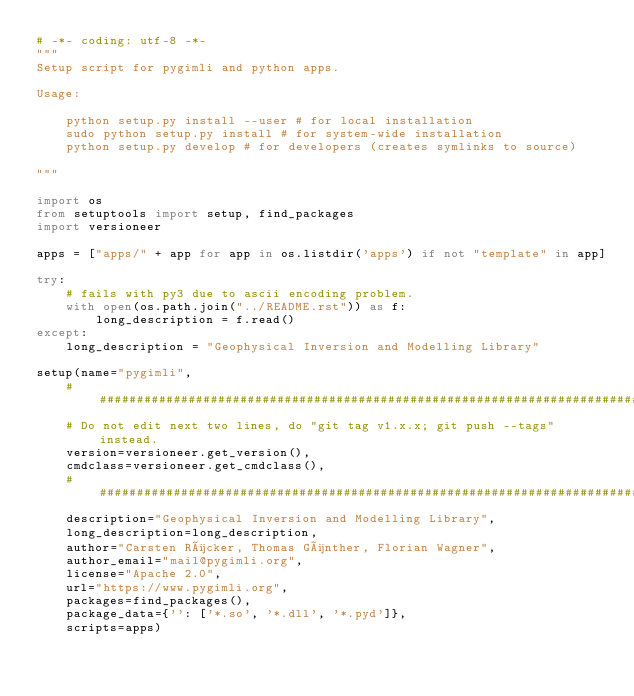<code> <loc_0><loc_0><loc_500><loc_500><_Python_># -*- coding: utf-8 -*-
"""
Setup script for pygimli and python apps.

Usage:

    python setup.py install --user # for local installation
    sudo python setup.py install # for system-wide installation
    python setup.py develop # for developers (creates symlinks to source)

"""

import os
from setuptools import setup, find_packages
import versioneer

apps = ["apps/" + app for app in os.listdir('apps') if not "template" in app]

try:
    # fails with py3 due to ascii encoding problem.
    with open(os.path.join("../README.rst")) as f:
        long_description = f.read()
except:
    long_description = "Geophysical Inversion and Modelling Library"

setup(name="pygimli",
    ############################################################################
    # Do not edit next two lines, do "git tag v1.x.x; git push --tags" instead.
    version=versioneer.get_version(),
    cmdclass=versioneer.get_cmdclass(),
    ############################################################################
    description="Geophysical Inversion and Modelling Library",
    long_description=long_description,
    author="Carsten Rücker, Thomas Günther, Florian Wagner",
    author_email="mail@pygimli.org",
    license="Apache 2.0",
    url="https://www.pygimli.org",
    packages=find_packages(),
    package_data={'': ['*.so', '*.dll', '*.pyd']},
    scripts=apps)
</code> 